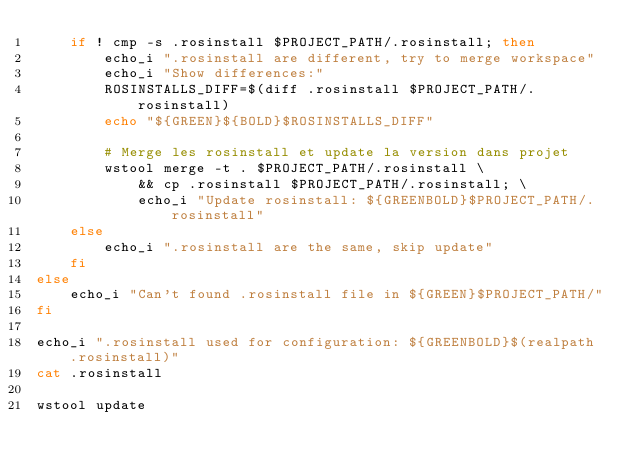Convert code to text. <code><loc_0><loc_0><loc_500><loc_500><_Bash_>	if ! cmp -s .rosinstall $PROJECT_PATH/.rosinstall; then
		echo_i ".rosinstall are different, try to merge workspace"
		echo_i "Show differences:"
		ROSINSTALLS_DIFF=$(diff .rosinstall $PROJECT_PATH/.rosinstall)
		echo "${GREEN}${BOLD}$ROSINSTALLS_DIFF"

		# Merge les rosinstall et update la version dans projet
		wstool merge -t . $PROJECT_PATH/.rosinstall \
			&& cp .rosinstall $PROJECT_PATH/.rosinstall; \
			echo_i "Update rosinstall: ${GREENBOLD}$PROJECT_PATH/.rosinstall"
	else
		echo_i ".rosinstall are the same, skip update"
	fi
else
	echo_i "Can't found .rosinstall file in ${GREEN}$PROJECT_PATH/"
fi

echo_i ".rosinstall used for configuration: ${GREENBOLD}$(realpath .rosinstall)"
cat .rosinstall

wstool update</code> 